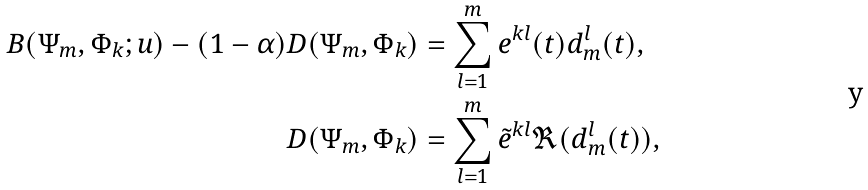Convert formula to latex. <formula><loc_0><loc_0><loc_500><loc_500>B ( \Psi _ { m } , \Phi _ { k } ; u ) - ( 1 - \alpha ) D ( \Psi _ { m } , \Phi _ { k } ) & = \sum _ { l = 1 } ^ { m } e ^ { k l } ( t ) d _ { m } ^ { l } ( t ) , \\ D ( \Psi _ { m } , \Phi _ { k } ) & = \sum _ { l = 1 } ^ { m } \tilde { e } ^ { k l } \Re ( d _ { m } ^ { l } ( t ) ) ,</formula> 